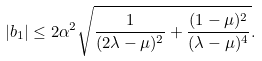<formula> <loc_0><loc_0><loc_500><loc_500>| b _ { 1 } | \leq 2 \alpha ^ { 2 } \sqrt { \frac { 1 } { ( 2 \lambda - \mu ) ^ { 2 } } + \frac { ( 1 - \mu ) ^ { 2 } } { ( \lambda - \mu ) ^ { 4 } } } .</formula> 